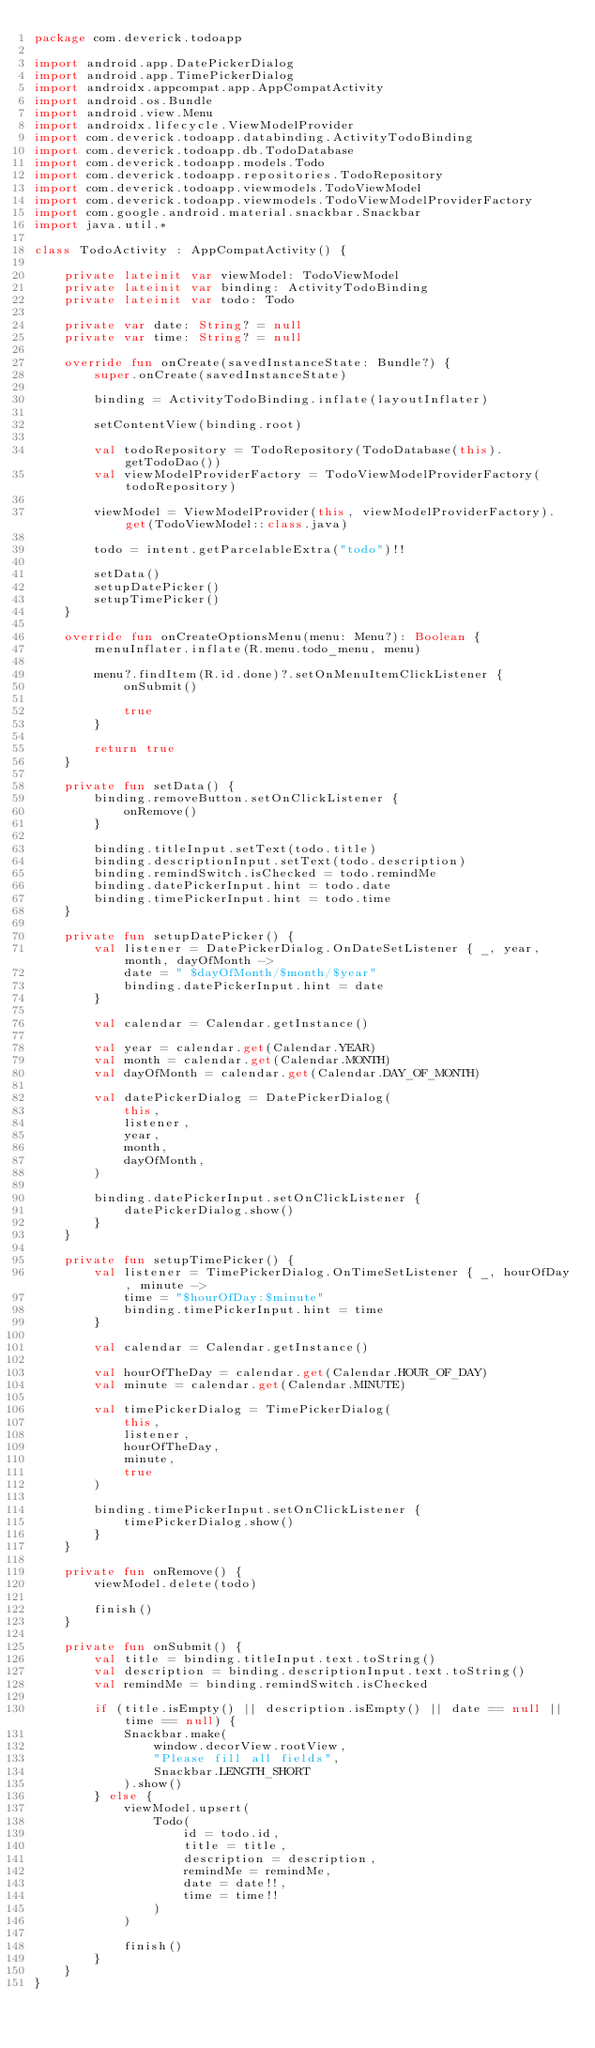Convert code to text. <code><loc_0><loc_0><loc_500><loc_500><_Kotlin_>package com.deverick.todoapp

import android.app.DatePickerDialog
import android.app.TimePickerDialog
import androidx.appcompat.app.AppCompatActivity
import android.os.Bundle
import android.view.Menu
import androidx.lifecycle.ViewModelProvider
import com.deverick.todoapp.databinding.ActivityTodoBinding
import com.deverick.todoapp.db.TodoDatabase
import com.deverick.todoapp.models.Todo
import com.deverick.todoapp.repositories.TodoRepository
import com.deverick.todoapp.viewmodels.TodoViewModel
import com.deverick.todoapp.viewmodels.TodoViewModelProviderFactory
import com.google.android.material.snackbar.Snackbar
import java.util.*

class TodoActivity : AppCompatActivity() {

    private lateinit var viewModel: TodoViewModel
    private lateinit var binding: ActivityTodoBinding
    private lateinit var todo: Todo

    private var date: String? = null
    private var time: String? = null

    override fun onCreate(savedInstanceState: Bundle?) {
        super.onCreate(savedInstanceState)

        binding = ActivityTodoBinding.inflate(layoutInflater)

        setContentView(binding.root)

        val todoRepository = TodoRepository(TodoDatabase(this).getTodoDao())
        val viewModelProviderFactory = TodoViewModelProviderFactory(todoRepository)

        viewModel = ViewModelProvider(this, viewModelProviderFactory).get(TodoViewModel::class.java)

        todo = intent.getParcelableExtra("todo")!!

        setData()
        setupDatePicker()
        setupTimePicker()
    }

    override fun onCreateOptionsMenu(menu: Menu?): Boolean {
        menuInflater.inflate(R.menu.todo_menu, menu)

        menu?.findItem(R.id.done)?.setOnMenuItemClickListener {
            onSubmit()

            true
        }

        return true
    }

    private fun setData() {
        binding.removeButton.setOnClickListener {
            onRemove()
        }

        binding.titleInput.setText(todo.title)
        binding.descriptionInput.setText(todo.description)
        binding.remindSwitch.isChecked = todo.remindMe
        binding.datePickerInput.hint = todo.date
        binding.timePickerInput.hint = todo.time
    }

    private fun setupDatePicker() {
        val listener = DatePickerDialog.OnDateSetListener { _, year, month, dayOfMonth ->
            date = " $dayOfMonth/$month/$year"
            binding.datePickerInput.hint = date
        }

        val calendar = Calendar.getInstance()

        val year = calendar.get(Calendar.YEAR)
        val month = calendar.get(Calendar.MONTH)
        val dayOfMonth = calendar.get(Calendar.DAY_OF_MONTH)

        val datePickerDialog = DatePickerDialog(
            this,
            listener,
            year,
            month,
            dayOfMonth,
        )

        binding.datePickerInput.setOnClickListener {
            datePickerDialog.show()
        }
    }

    private fun setupTimePicker() {
        val listener = TimePickerDialog.OnTimeSetListener { _, hourOfDay, minute ->
            time = "$hourOfDay:$minute"
            binding.timePickerInput.hint = time
        }

        val calendar = Calendar.getInstance()

        val hourOfTheDay = calendar.get(Calendar.HOUR_OF_DAY)
        val minute = calendar.get(Calendar.MINUTE)

        val timePickerDialog = TimePickerDialog(
            this,
            listener,
            hourOfTheDay,
            minute,
            true
        )

        binding.timePickerInput.setOnClickListener {
            timePickerDialog.show()
        }
    }

    private fun onRemove() {
        viewModel.delete(todo)

        finish()
    }

    private fun onSubmit() {
        val title = binding.titleInput.text.toString()
        val description = binding.descriptionInput.text.toString()
        val remindMe = binding.remindSwitch.isChecked

        if (title.isEmpty() || description.isEmpty() || date == null || time == null) {
            Snackbar.make(
                window.decorView.rootView,
                "Please fill all fields",
                Snackbar.LENGTH_SHORT
            ).show()
        } else {
            viewModel.upsert(
                Todo(
                    id = todo.id,
                    title = title,
                    description = description,
                    remindMe = remindMe,
                    date = date!!,
                    time = time!!
                )
            )

            finish()
        }
    }
}

</code> 